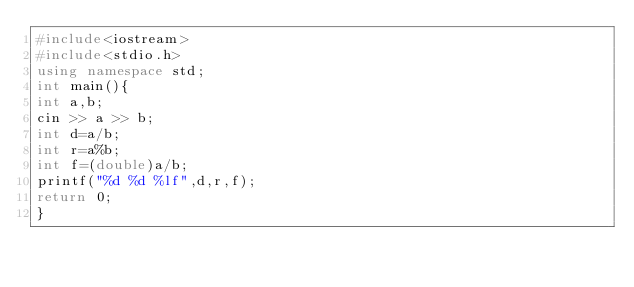Convert code to text. <code><loc_0><loc_0><loc_500><loc_500><_C++_>#include<iostream>
#include<stdio.h>
using namespace std;
int main(){
int a,b;
cin >> a >> b;
int d=a/b;
int r=a%b;
int f=(double)a/b;
printf("%d %d %lf",d,r,f);
return 0;
}

</code> 